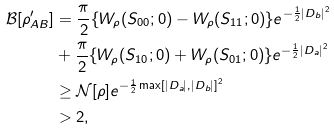Convert formula to latex. <formula><loc_0><loc_0><loc_500><loc_500>\mathcal { B } [ \rho ^ { \prime } _ { A B } ] & = \frac { \pi } { 2 } \{ W _ { \rho } ( S _ { 0 0 } ; 0 ) - W _ { \rho } ( S _ { 1 1 } ; 0 ) \} e ^ { - \frac { 1 } { 2 } | D _ { b } | ^ { 2 } } \\ & + \frac { \pi } { 2 } \{ W _ { \rho } ( S _ { 1 0 } ; 0 ) + W _ { \rho } ( S _ { 0 1 } ; 0 ) \} e ^ { - \frac { 1 } { 2 } | D _ { a } | ^ { 2 } } \\ & \geq \mathcal { N } [ \rho ] e ^ { - \frac { 1 } { 2 } \max [ | D _ { a } | , | D _ { b } | ] ^ { 2 } } \\ & > 2 ,</formula> 